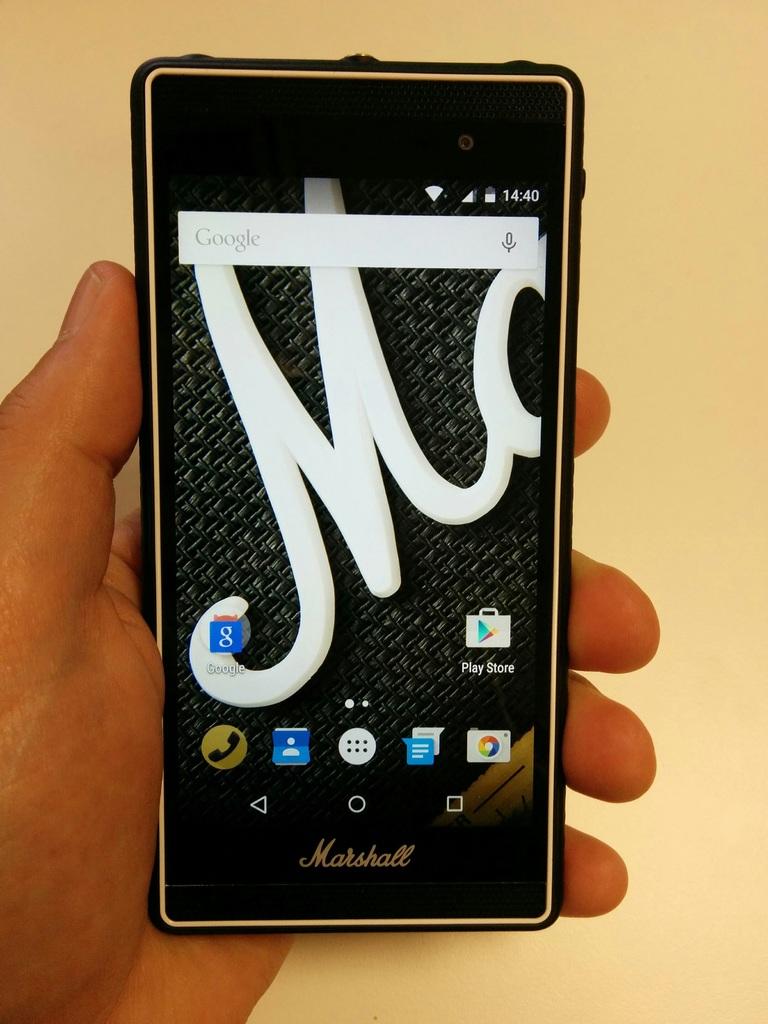Who creates the smartphone being held?
Give a very brief answer. Marshall. 